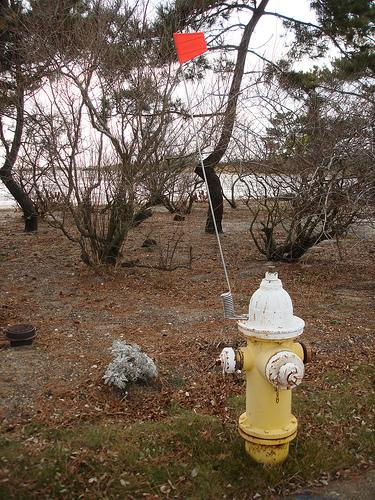Question: when was the photo taken?
Choices:
A. At dawn.
B. At dusk.
C. In the morning.
D. The afternoon.
Answer with the letter. Answer: D Question: why is the day not bright?
Choices:
A. Rainy Season.
B. Sun behind the cloud.
C. Evening.
D. Cloudy.
Answer with the letter. Answer: D Question: where is the hydrant?
Choices:
A. The road.
B. The driveway.
C. The fire station.
D. The grass.
Answer with the letter. Answer: D Question: what color is the flag?
Choices:
A. Yellow.
B. Red.
C. White.
D. Orange.
Answer with the letter. Answer: D Question: what is on the grass?
Choices:
A. Apples.
B. Ornaments.
C. Leaves.
D. A kiddie pool.
Answer with the letter. Answer: C 